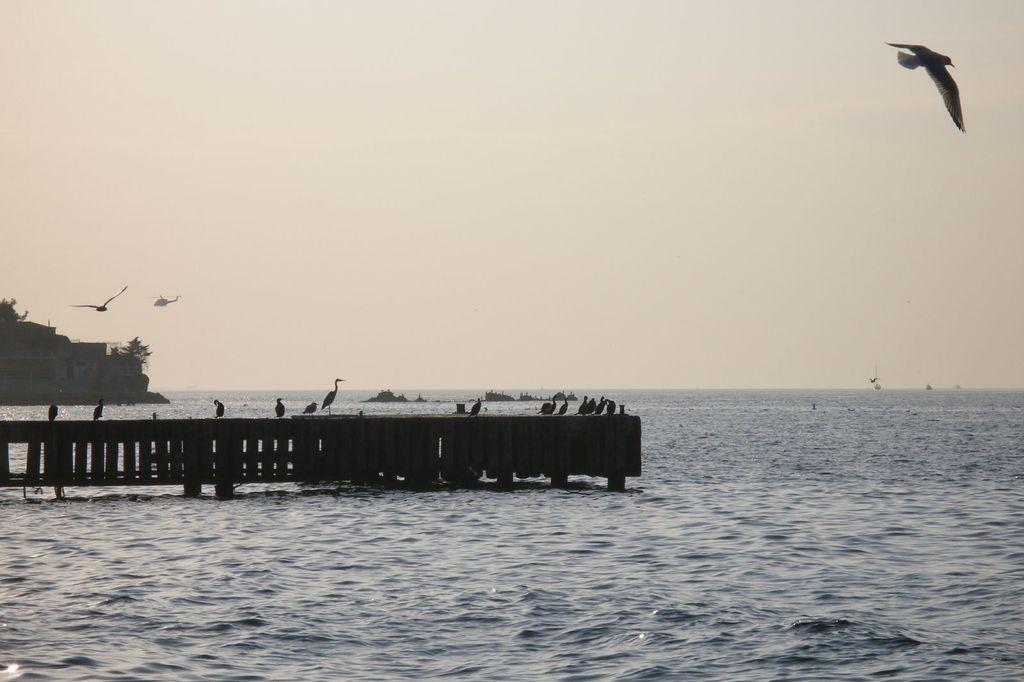What is the primary setting of the image? The image consists of a sea. What type of animals can be seen in the image? There are birds flying in the image. Are there any birds standing on a surface in the image? Yes, some birds are standing on a wooden base. What other type of vehicle can be seen in the image besides the birds? There is a helicopter flying in the image. What scientific discovery is being made by the birds in the image? There is no indication of a scientific discovery being made by the birds in the image. 